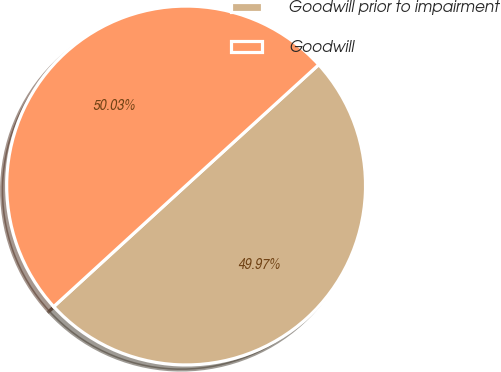Convert chart to OTSL. <chart><loc_0><loc_0><loc_500><loc_500><pie_chart><fcel>Goodwill prior to impairment<fcel>Goodwill<nl><fcel>49.97%<fcel>50.03%<nl></chart> 